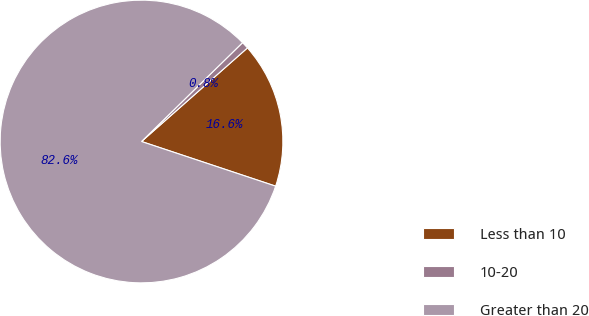Convert chart to OTSL. <chart><loc_0><loc_0><loc_500><loc_500><pie_chart><fcel>Less than 10<fcel>10-20<fcel>Greater than 20<nl><fcel>16.63%<fcel>0.81%<fcel>82.55%<nl></chart> 